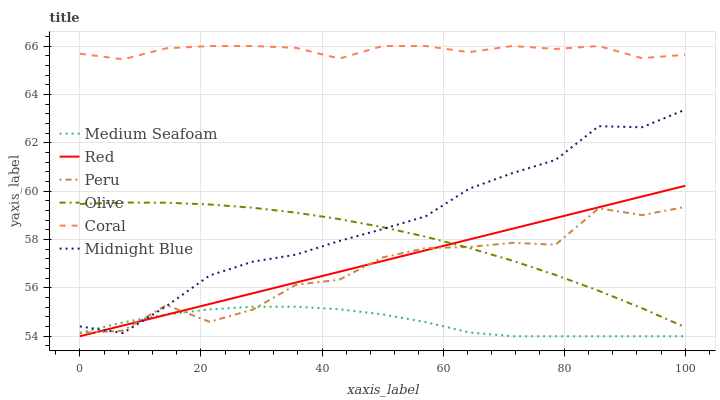Does Medium Seafoam have the minimum area under the curve?
Answer yes or no. Yes. Does Coral have the maximum area under the curve?
Answer yes or no. Yes. Does Peru have the minimum area under the curve?
Answer yes or no. No. Does Peru have the maximum area under the curve?
Answer yes or no. No. Is Red the smoothest?
Answer yes or no. Yes. Is Peru the roughest?
Answer yes or no. Yes. Is Coral the smoothest?
Answer yes or no. No. Is Coral the roughest?
Answer yes or no. No. Does Medium Seafoam have the lowest value?
Answer yes or no. Yes. Does Peru have the lowest value?
Answer yes or no. No. Does Coral have the highest value?
Answer yes or no. Yes. Does Peru have the highest value?
Answer yes or no. No. Is Midnight Blue less than Coral?
Answer yes or no. Yes. Is Coral greater than Medium Seafoam?
Answer yes or no. Yes. Does Red intersect Medium Seafoam?
Answer yes or no. Yes. Is Red less than Medium Seafoam?
Answer yes or no. No. Is Red greater than Medium Seafoam?
Answer yes or no. No. Does Midnight Blue intersect Coral?
Answer yes or no. No. 